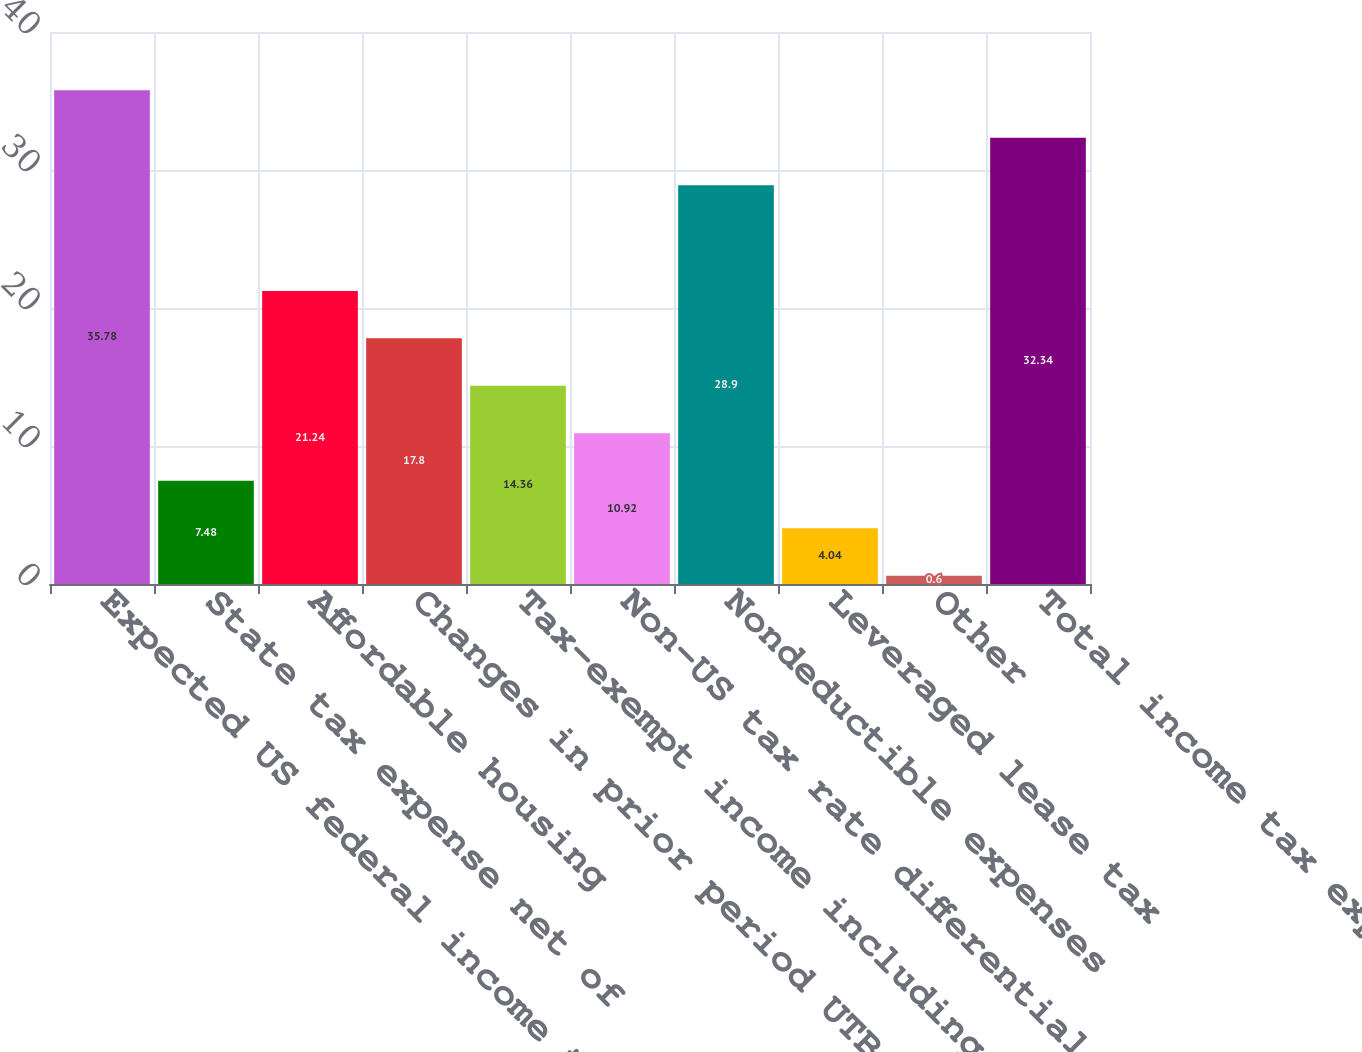Convert chart to OTSL. <chart><loc_0><loc_0><loc_500><loc_500><bar_chart><fcel>Expected US federal income tax<fcel>State tax expense net of<fcel>Affordable housing<fcel>Changes in prior period UTBs<fcel>Tax-exempt income including<fcel>Non-US tax rate differential<fcel>Nondeductible expenses<fcel>Leveraged lease tax<fcel>Other<fcel>Total income tax expense<nl><fcel>35.78<fcel>7.48<fcel>21.24<fcel>17.8<fcel>14.36<fcel>10.92<fcel>28.9<fcel>4.04<fcel>0.6<fcel>32.34<nl></chart> 